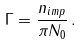<formula> <loc_0><loc_0><loc_500><loc_500>\Gamma = \frac { n _ { i m p } } { \pi N _ { 0 } } \, .</formula> 